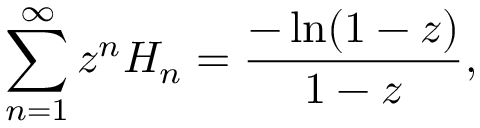<formula> <loc_0><loc_0><loc_500><loc_500>\sum _ { n = 1 } ^ { \infty } z ^ { n } H _ { n } = { \frac { - \ln ( 1 - z ) } { 1 - z } } ,</formula> 